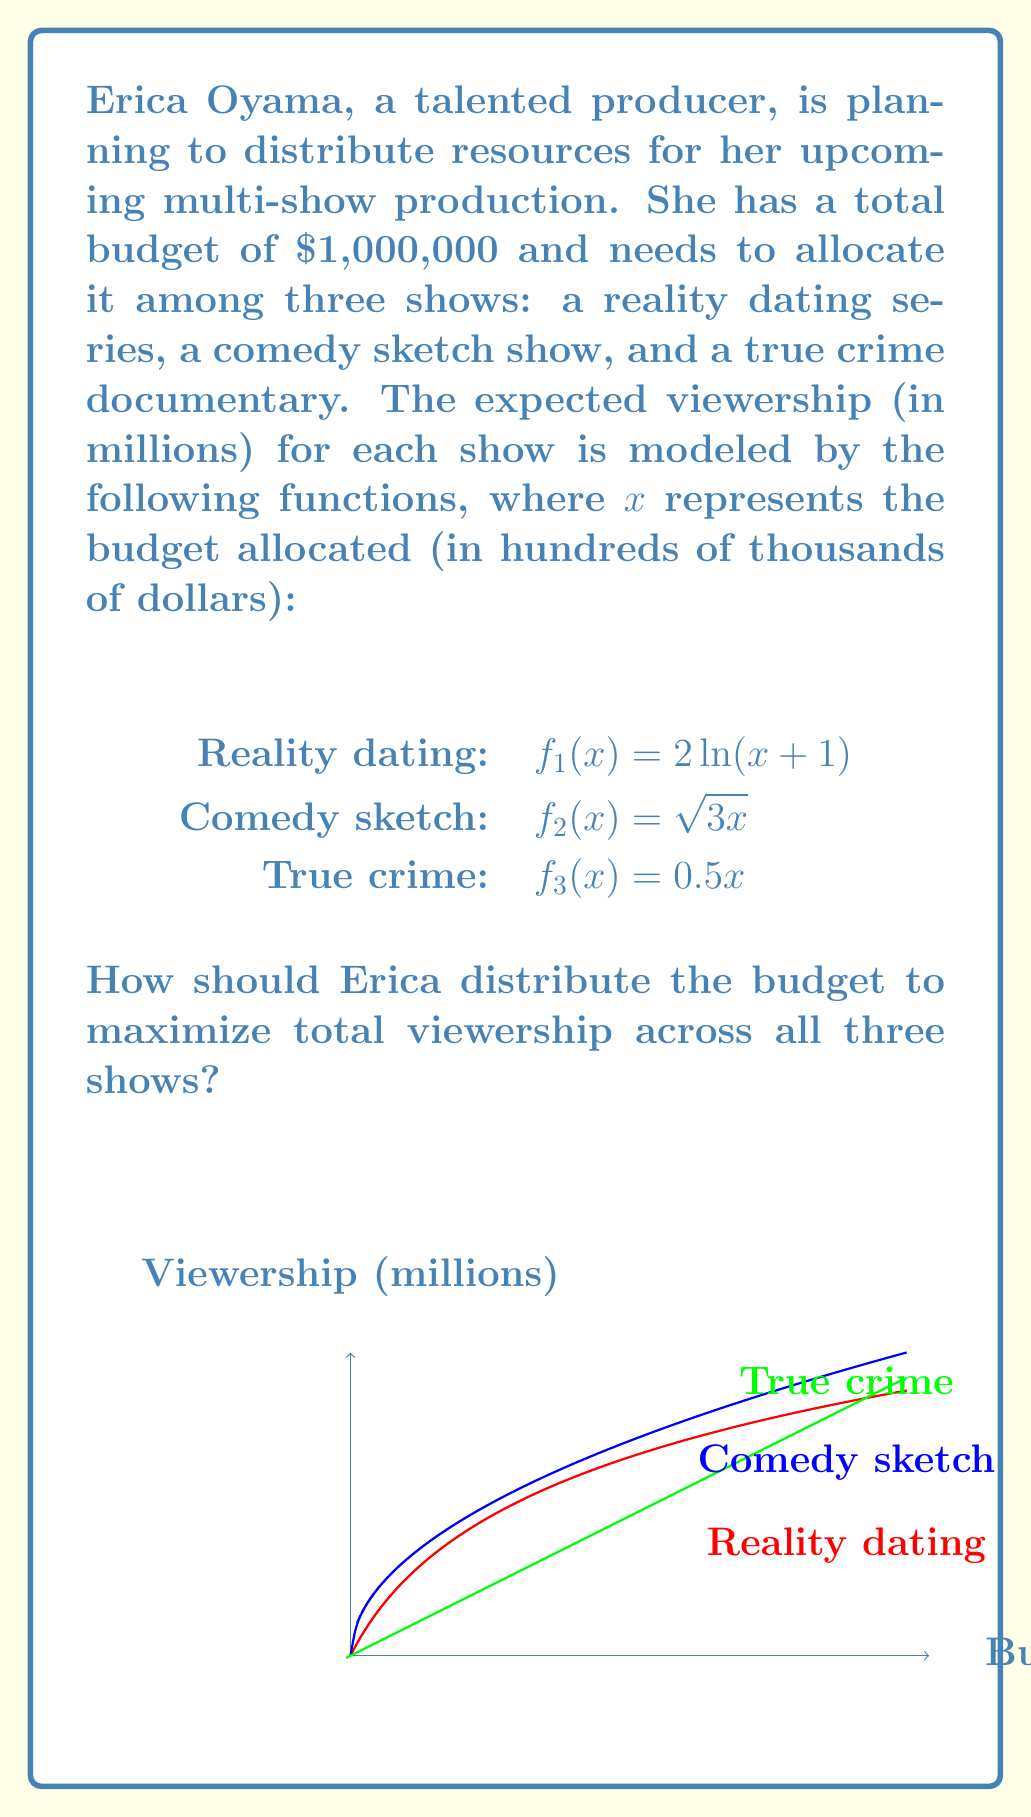Help me with this question. To solve this optimization problem, we'll use the method of Lagrange multipliers:

1) Let $x$, $y$, and $z$ be the budgets (in hundreds of thousands of dollars) for reality dating, comedy sketch, and true crime shows respectively.

2) Our objective function is the total viewership:
   $$V(x,y,z) = 2\ln(x+1) + \sqrt{3y} + 0.5z$$

3) The constraint is the total budget:
   $$g(x,y,z) = x + y + z - 10 = 0$$ (since $1,000,000 = 10 * 100,000)

4) We form the Lagrangian:
   $$L(x,y,z,\lambda) = 2\ln(x+1) + \sqrt{3y} + 0.5z - \lambda(x + y + z - 10)$$

5) We set the partial derivatives equal to zero:
   $$\frac{\partial L}{\partial x} = \frac{2}{x+1} - \lambda = 0$$
   $$\frac{\partial L}{\partial y} = \frac{\sqrt{3}}{2\sqrt{y}} - \lambda = 0$$
   $$\frac{\partial L}{\partial z} = 0.5 - \lambda = 0$$
   $$\frac{\partial L}{\partial \lambda} = x + y + z - 10 = 0$$

6) From the third equation, we get $\lambda = 0.5$

7) Substituting this into the first two equations:
   $$\frac{2}{x+1} = 0.5 \implies x = 3$$
   $$\frac{\sqrt{3}}{2\sqrt{y}} = 0.5 \implies y = 3$$

8) From the constraint equation:
   $$3 + 3 + z = 10 \implies z = 4$$

9) Therefore, the optimal budget allocation is:
   Reality dating: $300,000
   Comedy sketch: $300,000
   True crime: $400,000

10) We can verify that this gives the maximum viewership:
    $$V(3,3,4) = 2\ln(4) + \sqrt{9} + 0.5(4) = 2.77 + 3 + 2 = 7.77$$ million viewers
Answer: Reality dating: $300,000, Comedy sketch: $300,000, True crime: $400,000 